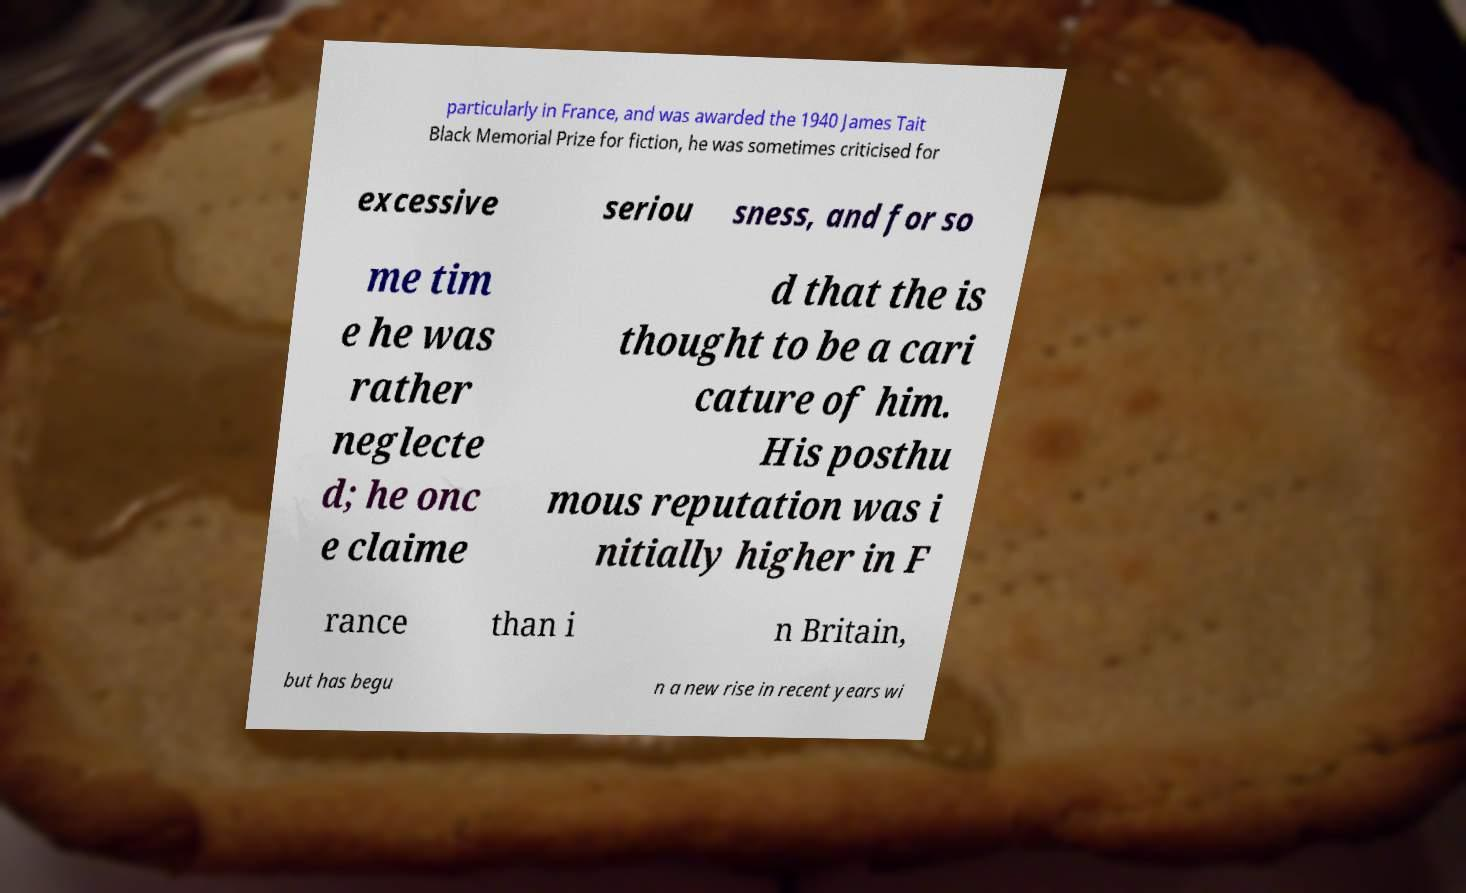For documentation purposes, I need the text within this image transcribed. Could you provide that? particularly in France, and was awarded the 1940 James Tait Black Memorial Prize for fiction, he was sometimes criticised for excessive seriou sness, and for so me tim e he was rather neglecte d; he onc e claime d that the is thought to be a cari cature of him. His posthu mous reputation was i nitially higher in F rance than i n Britain, but has begu n a new rise in recent years wi 